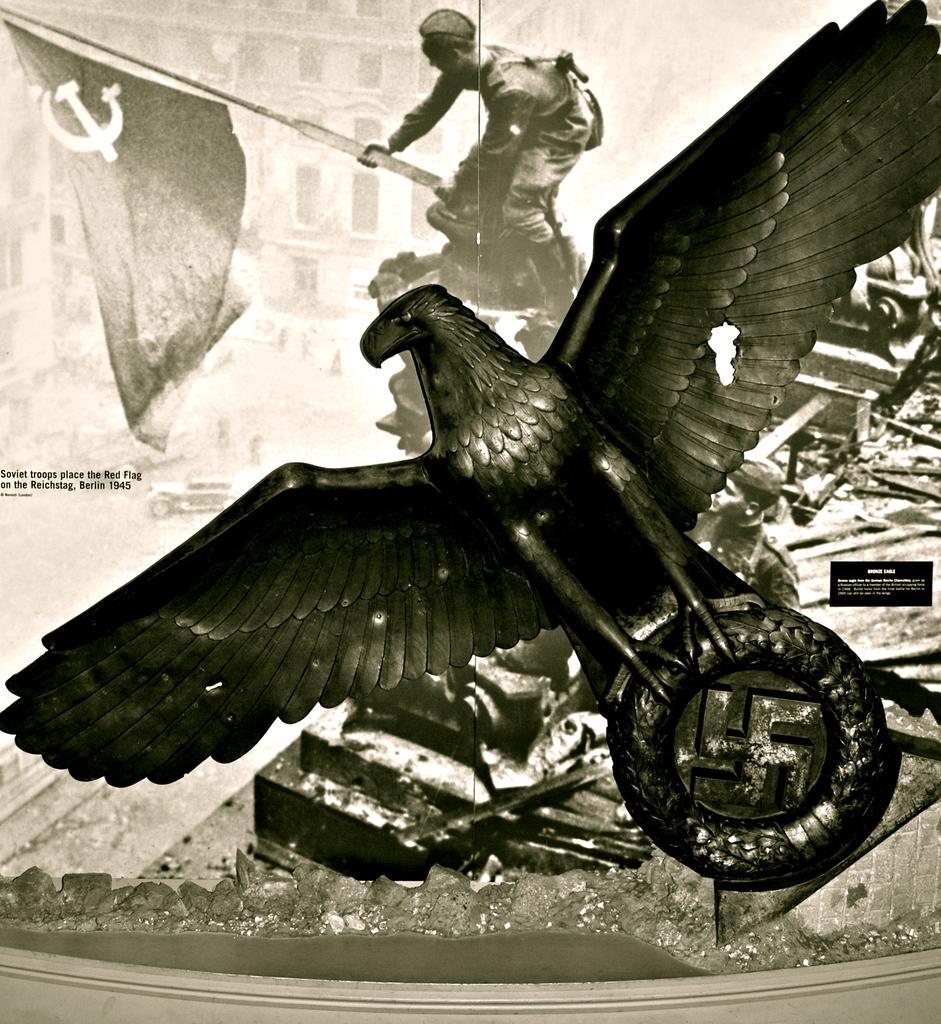Please provide a concise description of this image. In this image we can see a black and white picture of an eagle statue. In the background, we can see a photo of a person holding a flag in his hand. 